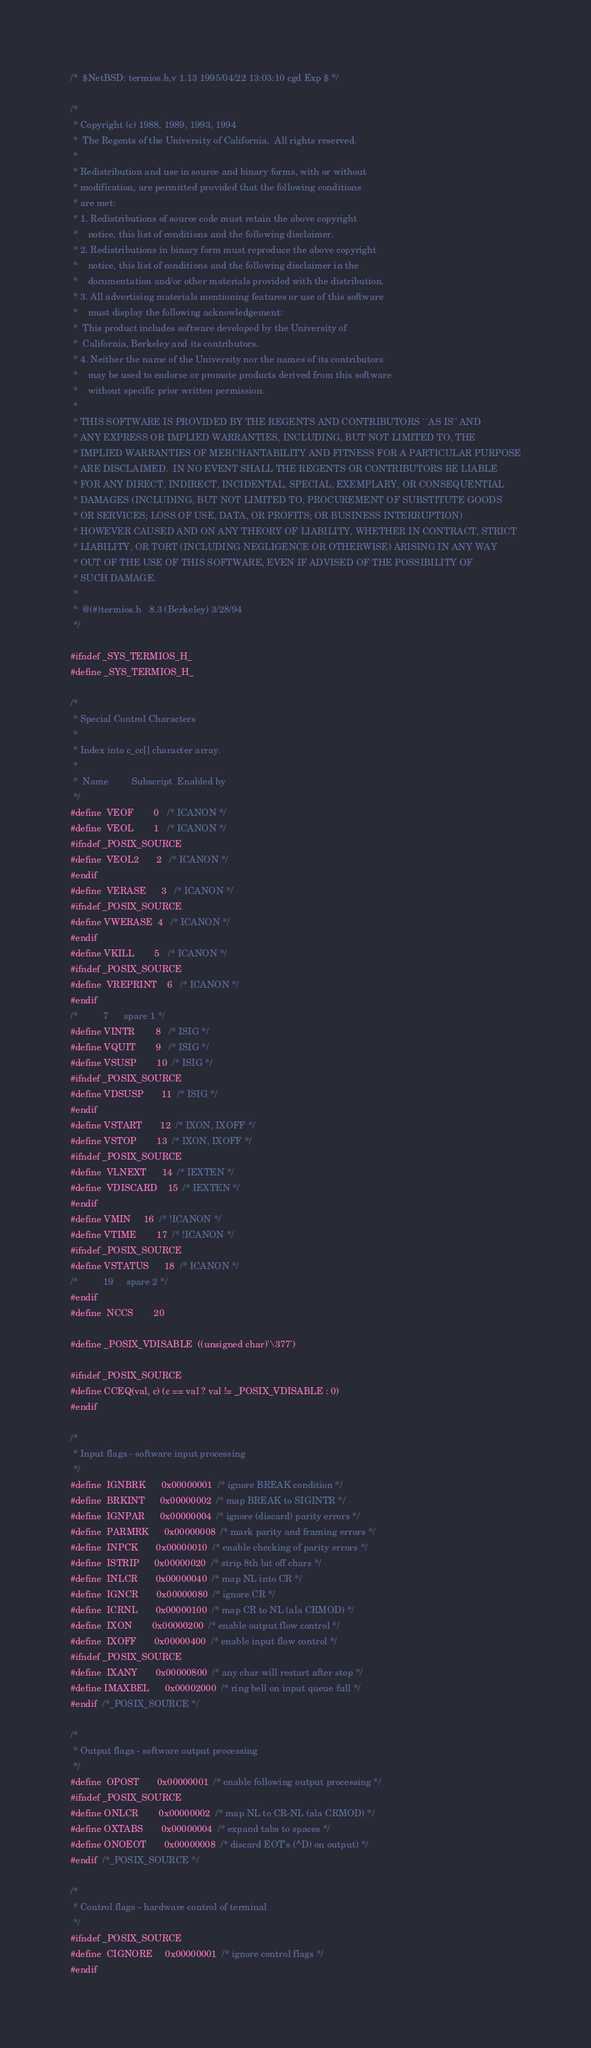<code> <loc_0><loc_0><loc_500><loc_500><_C_>/*	$NetBSD: termios.h,v 1.13 1995/04/22 13:03:10 cgd Exp $	*/

/*
 * Copyright (c) 1988, 1989, 1993, 1994
 *	The Regents of the University of California.  All rights reserved.
 *
 * Redistribution and use in source and binary forms, with or without
 * modification, are permitted provided that the following conditions
 * are met:
 * 1. Redistributions of source code must retain the above copyright
 *    notice, this list of conditions and the following disclaimer.
 * 2. Redistributions in binary form must reproduce the above copyright
 *    notice, this list of conditions and the following disclaimer in the
 *    documentation and/or other materials provided with the distribution.
 * 3. All advertising materials mentioning features or use of this software
 *    must display the following acknowledgement:
 *	This product includes software developed by the University of
 *	California, Berkeley and its contributors.
 * 4. Neither the name of the University nor the names of its contributors
 *    may be used to endorse or promote products derived from this software
 *    without specific prior written permission.
 *
 * THIS SOFTWARE IS PROVIDED BY THE REGENTS AND CONTRIBUTORS ``AS IS'' AND
 * ANY EXPRESS OR IMPLIED WARRANTIES, INCLUDING, BUT NOT LIMITED TO, THE
 * IMPLIED WARRANTIES OF MERCHANTABILITY AND FITNESS FOR A PARTICULAR PURPOSE
 * ARE DISCLAIMED.  IN NO EVENT SHALL THE REGENTS OR CONTRIBUTORS BE LIABLE
 * FOR ANY DIRECT, INDIRECT, INCIDENTAL, SPECIAL, EXEMPLARY, OR CONSEQUENTIAL
 * DAMAGES (INCLUDING, BUT NOT LIMITED TO, PROCUREMENT OF SUBSTITUTE GOODS
 * OR SERVICES; LOSS OF USE, DATA, OR PROFITS; OR BUSINESS INTERRUPTION)
 * HOWEVER CAUSED AND ON ANY THEORY OF LIABILITY, WHETHER IN CONTRACT, STRICT
 * LIABILITY, OR TORT (INCLUDING NEGLIGENCE OR OTHERWISE) ARISING IN ANY WAY
 * OUT OF THE USE OF THIS SOFTWARE, EVEN IF ADVISED OF THE POSSIBILITY OF
 * SUCH DAMAGE.
 *
 *	@(#)termios.h	8.3 (Berkeley) 3/28/94
 */

#ifndef _SYS_TERMIOS_H_
#define _SYS_TERMIOS_H_

/* 
 * Special Control Characters 
 *
 * Index into c_cc[] character array.
 *
 *	Name	     Subscript	Enabled by 
 */
#define	VEOF		0	/* ICANON */
#define	VEOL		1	/* ICANON */
#ifndef _POSIX_SOURCE
#define	VEOL2		2	/* ICANON */
#endif
#define	VERASE		3	/* ICANON */
#ifndef _POSIX_SOURCE
#define VWERASE 	4	/* ICANON */
#endif 
#define VKILL		5	/* ICANON */
#ifndef _POSIX_SOURCE
#define	VREPRINT 	6	/* ICANON */
#endif
/*			7	   spare 1 */
#define VINTR		8	/* ISIG */
#define VQUIT		9	/* ISIG */
#define VSUSP		10	/* ISIG */
#ifndef _POSIX_SOURCE
#define VDSUSP		11	/* ISIG */
#endif
#define VSTART		12	/* IXON, IXOFF */
#define VSTOP		13	/* IXON, IXOFF */
#ifndef _POSIX_SOURCE
#define	VLNEXT		14	/* IEXTEN */
#define	VDISCARD	15	/* IEXTEN */
#endif
#define VMIN		16	/* !ICANON */
#define VTIME		17	/* !ICANON */
#ifndef _POSIX_SOURCE
#define VSTATUS		18	/* ICANON */
/*			19	   spare 2 */
#endif
#define	NCCS		20

#define _POSIX_VDISABLE	((unsigned char)'\377')

#ifndef _POSIX_SOURCE
#define CCEQ(val, c)	(c == val ? val != _POSIX_VDISABLE : 0)
#endif

/*
 * Input flags - software input processing
 */
#define	IGNBRK		0x00000001	/* ignore BREAK condition */
#define	BRKINT		0x00000002	/* map BREAK to SIGINTR */
#define	IGNPAR		0x00000004	/* ignore (discard) parity errors */
#define	PARMRK		0x00000008	/* mark parity and framing errors */
#define	INPCK		0x00000010	/* enable checking of parity errors */
#define	ISTRIP		0x00000020	/* strip 8th bit off chars */
#define	INLCR		0x00000040	/* map NL into CR */
#define	IGNCR		0x00000080	/* ignore CR */
#define	ICRNL		0x00000100	/* map CR to NL (ala CRMOD) */
#define	IXON		0x00000200	/* enable output flow control */
#define	IXOFF		0x00000400	/* enable input flow control */
#ifndef _POSIX_SOURCE
#define	IXANY		0x00000800	/* any char will restart after stop */
#define IMAXBEL		0x00002000	/* ring bell on input queue full */
#endif  /*_POSIX_SOURCE */

/*
 * Output flags - software output processing
 */
#define	OPOST		0x00000001	/* enable following output processing */
#ifndef _POSIX_SOURCE
#define ONLCR		0x00000002	/* map NL to CR-NL (ala CRMOD) */
#define OXTABS		0x00000004	/* expand tabs to spaces */
#define ONOEOT		0x00000008	/* discard EOT's (^D) on output) */
#endif  /*_POSIX_SOURCE */

/*
 * Control flags - hardware control of terminal
 */
#ifndef _POSIX_SOURCE
#define	CIGNORE		0x00000001	/* ignore control flags */
#endif</code> 